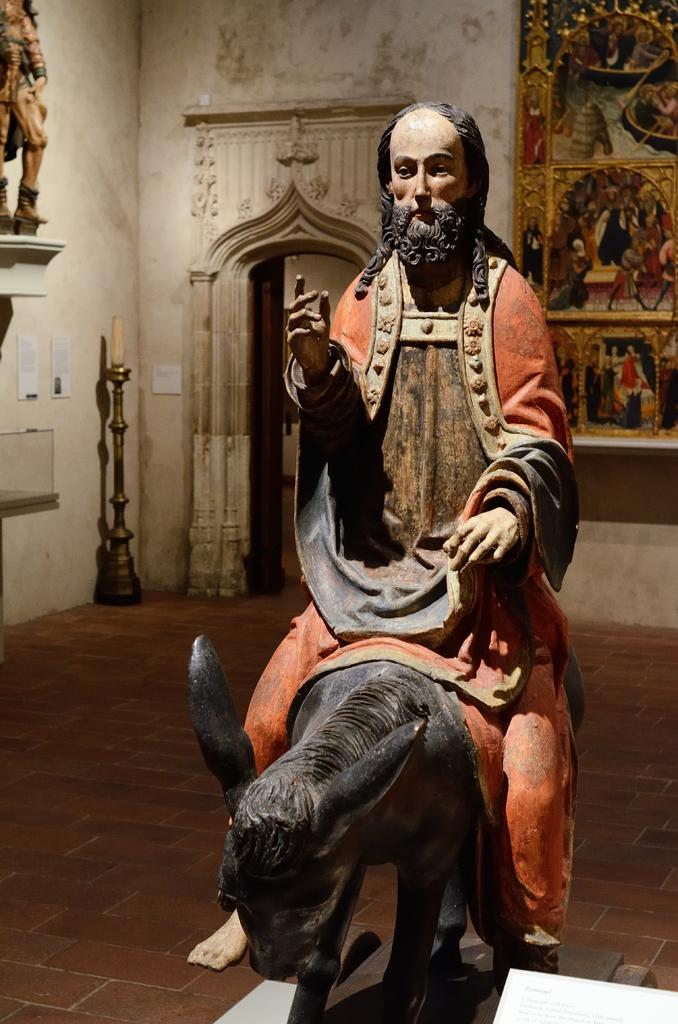What is the main subject of the image? There is a statue of an animal in the image. What is the person in the image doing? A person is sitting on the statue. How is the statue positioned in the image? The statue is on a platform. What can be seen in the background of the image? There is a wall and objects visible in the background. What type of nose does the statue have in the image? The statue does not have a nose, as it is an animal statue and animals do not have noses like humans. 